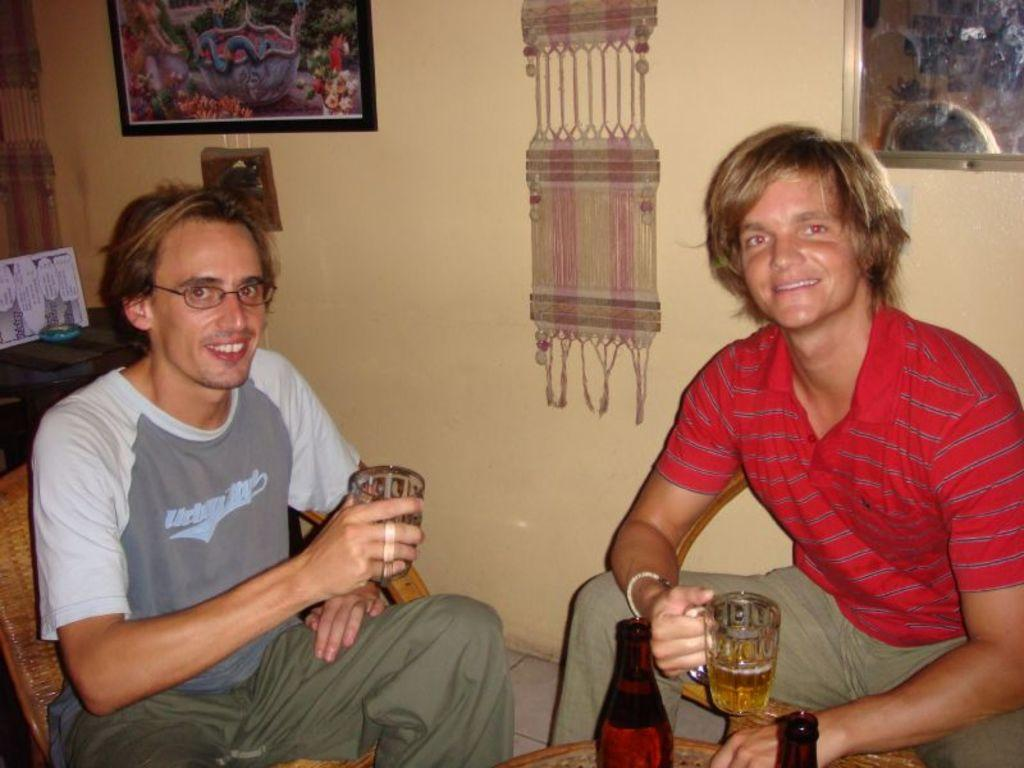How many people are in the image? There are two persons in the image. What are the persons doing in the image? The persons are sitting on chairs and smiling. What are the persons holding in the image? The persons are holding wine glasses. What can be seen on the wall in the image? There is a photo frame on the wall. What type of reaction can be seen from the baseball in the image? There is no baseball present in the image, so it is not possible to determine any reaction. 